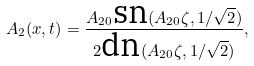<formula> <loc_0><loc_0><loc_500><loc_500>A _ { 2 } ( x , t ) = \frac { A _ { 2 0 } \text {sn} ( A _ { 2 0 } \zeta , 1 / \sqrt { 2 } ) } { 2 \text {dn} ( A _ { 2 0 } \zeta , 1 / \sqrt { 2 } ) } ,</formula> 